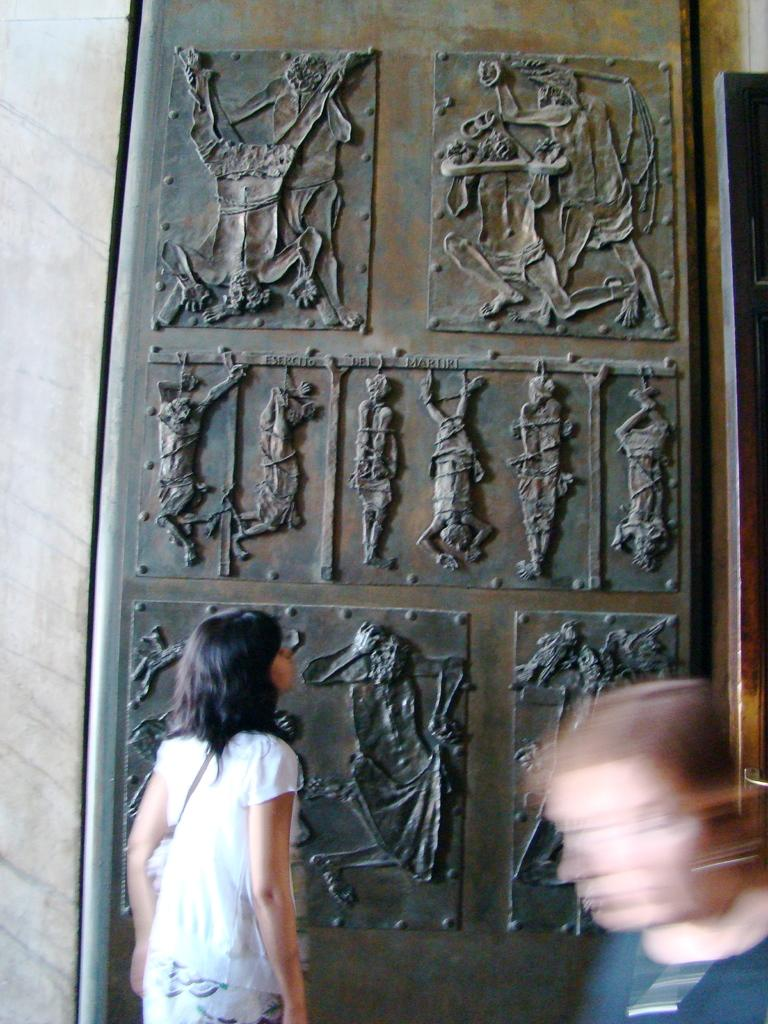Who is the main subject in the image? There is a girl in the image. Where is the girl positioned in the image? The girl is standing on the left side of the image. What is the girl doing in the image? The girl is observing carvings. What is the girl wearing in the image? The girl is wearing a white dress. What type of office equipment can be seen in the image? There is no office equipment present in the image. What tool is the girl using to interact with the carvings in the image? The girl is not using any tool to interact with the carvings in the image; she is merely observing them. 